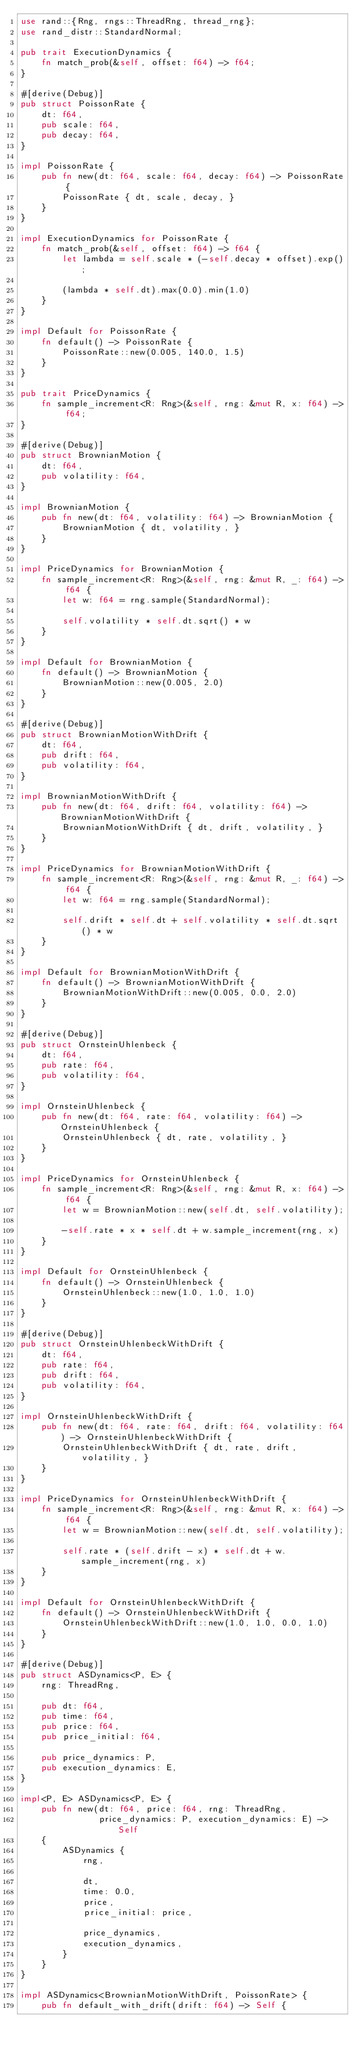<code> <loc_0><loc_0><loc_500><loc_500><_Rust_>use rand::{Rng, rngs::ThreadRng, thread_rng};
use rand_distr::StandardNormal;

pub trait ExecutionDynamics {
    fn match_prob(&self, offset: f64) -> f64;
}

#[derive(Debug)]
pub struct PoissonRate {
    dt: f64,
    pub scale: f64,
    pub decay: f64,
}

impl PoissonRate {
    pub fn new(dt: f64, scale: f64, decay: f64) -> PoissonRate {
        PoissonRate { dt, scale, decay, }
    }
}

impl ExecutionDynamics for PoissonRate {
    fn match_prob(&self, offset: f64) -> f64 {
        let lambda = self.scale * (-self.decay * offset).exp();

        (lambda * self.dt).max(0.0).min(1.0)
    }
}

impl Default for PoissonRate {
    fn default() -> PoissonRate {
        PoissonRate::new(0.005, 140.0, 1.5)
    }
}

pub trait PriceDynamics {
    fn sample_increment<R: Rng>(&self, rng: &mut R, x: f64) -> f64;
}

#[derive(Debug)]
pub struct BrownianMotion {
    dt: f64,
    pub volatility: f64,
}

impl BrownianMotion {
    pub fn new(dt: f64, volatility: f64) -> BrownianMotion {
        BrownianMotion { dt, volatility, }
    }
}

impl PriceDynamics for BrownianMotion {
    fn sample_increment<R: Rng>(&self, rng: &mut R, _: f64) -> f64 {
        let w: f64 = rng.sample(StandardNormal);

        self.volatility * self.dt.sqrt() * w
    }
}

impl Default for BrownianMotion {
    fn default() -> BrownianMotion {
        BrownianMotion::new(0.005, 2.0)
    }
}

#[derive(Debug)]
pub struct BrownianMotionWithDrift {
    dt: f64,
    pub drift: f64,
    pub volatility: f64,
}

impl BrownianMotionWithDrift {
    pub fn new(dt: f64, drift: f64, volatility: f64) -> BrownianMotionWithDrift {
        BrownianMotionWithDrift { dt, drift, volatility, }
    }
}

impl PriceDynamics for BrownianMotionWithDrift {
    fn sample_increment<R: Rng>(&self, rng: &mut R, _: f64) -> f64 {
        let w: f64 = rng.sample(StandardNormal);

        self.drift * self.dt + self.volatility * self.dt.sqrt() * w
    }
}

impl Default for BrownianMotionWithDrift {
    fn default() -> BrownianMotionWithDrift {
        BrownianMotionWithDrift::new(0.005, 0.0, 2.0)
    }
}

#[derive(Debug)]
pub struct OrnsteinUhlenbeck {
    dt: f64,
    pub rate: f64,
    pub volatility: f64,
}

impl OrnsteinUhlenbeck {
    pub fn new(dt: f64, rate: f64, volatility: f64) -> OrnsteinUhlenbeck {
        OrnsteinUhlenbeck { dt, rate, volatility, }
    }
}

impl PriceDynamics for OrnsteinUhlenbeck {
    fn sample_increment<R: Rng>(&self, rng: &mut R, x: f64) -> f64 {
        let w = BrownianMotion::new(self.dt, self.volatility);

        -self.rate * x * self.dt + w.sample_increment(rng, x)
    }
}

impl Default for OrnsteinUhlenbeck {
    fn default() -> OrnsteinUhlenbeck {
        OrnsteinUhlenbeck::new(1.0, 1.0, 1.0)
    }
}

#[derive(Debug)]
pub struct OrnsteinUhlenbeckWithDrift {
    dt: f64,
    pub rate: f64,
    pub drift: f64,
    pub volatility: f64,
}

impl OrnsteinUhlenbeckWithDrift {
    pub fn new(dt: f64, rate: f64, drift: f64, volatility: f64) -> OrnsteinUhlenbeckWithDrift {
        OrnsteinUhlenbeckWithDrift { dt, rate, drift, volatility, }
    }
}

impl PriceDynamics for OrnsteinUhlenbeckWithDrift {
    fn sample_increment<R: Rng>(&self, rng: &mut R, x: f64) -> f64 {
        let w = BrownianMotion::new(self.dt, self.volatility);

        self.rate * (self.drift - x) * self.dt + w.sample_increment(rng, x)
    }
}

impl Default for OrnsteinUhlenbeckWithDrift {
    fn default() -> OrnsteinUhlenbeckWithDrift {
        OrnsteinUhlenbeckWithDrift::new(1.0, 1.0, 0.0, 1.0)
    }
}

#[derive(Debug)]
pub struct ASDynamics<P, E> {
    rng: ThreadRng,

    pub dt: f64,
    pub time: f64,
    pub price: f64,
    pub price_initial: f64,

    pub price_dynamics: P,
    pub execution_dynamics: E,
}

impl<P, E> ASDynamics<P, E> {
    pub fn new(dt: f64, price: f64, rng: ThreadRng,
               price_dynamics: P, execution_dynamics: E) -> Self
    {
        ASDynamics {
            rng,

            dt,
            time: 0.0,
            price,
            price_initial: price,

            price_dynamics,
            execution_dynamics,
        }
    }
}

impl ASDynamics<BrownianMotionWithDrift, PoissonRate> {
    pub fn default_with_drift(drift: f64) -> Self {</code> 